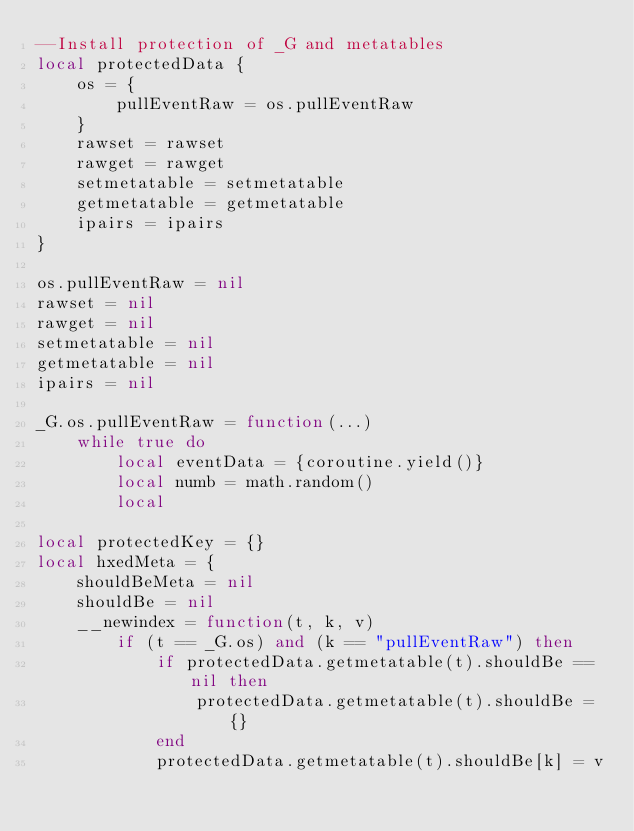Convert code to text. <code><loc_0><loc_0><loc_500><loc_500><_Lua_>--Install protection of _G and metatables
local protectedData {
    os = {
        pullEventRaw = os.pullEventRaw
    }
    rawset = rawset
    rawget = rawget
    setmetatable = setmetatable
    getmetatable = getmetatable
    ipairs = ipairs
}

os.pullEventRaw = nil
rawset = nil
rawget = nil
setmetatable = nil
getmetatable = nil
ipairs = nil

_G.os.pullEventRaw = function(...)
    while true do
        local eventData = {coroutine.yield()}
        local numb = math.random()
        local 

local protectedKey = {}
local hxedMeta = {
    shouldBeMeta = nil
    shouldBe = nil
    __newindex = function(t, k, v)
        if (t == _G.os) and (k == "pullEventRaw") then
            if protectedData.getmetatable(t).shouldBe == nil then
                protectedData.getmetatable(t).shouldBe = {}
            end
            protectedData.getmetatable(t).shouldBe[k] = v
</code> 